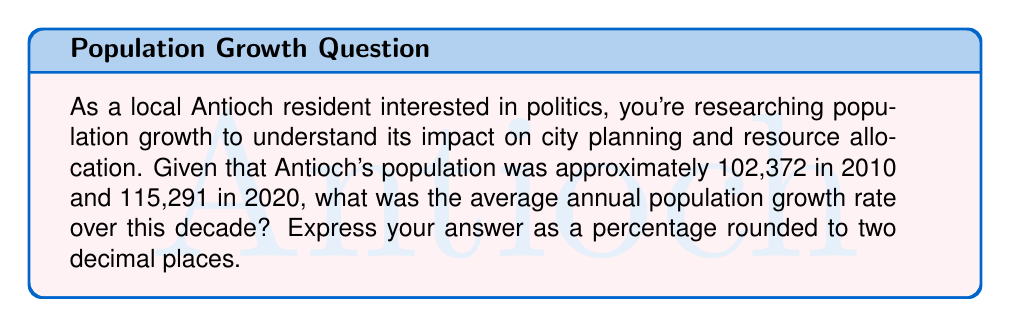What is the answer to this math problem? To solve this problem, we'll use the compound annual growth rate (CAGR) formula:

$$ CAGR = \left(\frac{Ending Value}{Beginning Value}\right)^{\frac{1}{n}} - 1 $$

Where:
- Ending Value is the population in 2020: 115,291
- Beginning Value is the population in 2010: 102,372
- n is the number of years: 10

Let's plug these values into the formula:

$$ CAGR = \left(\frac{115,291}{102,372}\right)^{\frac{1}{10}} - 1 $$

$$ CAGR = (1.1261)^{0.1} - 1 $$

$$ CAGR = 1.0119 - 1 $$

$$ CAGR = 0.0119 $$

To convert this to a percentage, we multiply by 100:

$$ CAGR\% = 0.0119 \times 100 = 1.19\% $$

Rounding to two decimal places, we get 1.19%.
Answer: 1.19% 